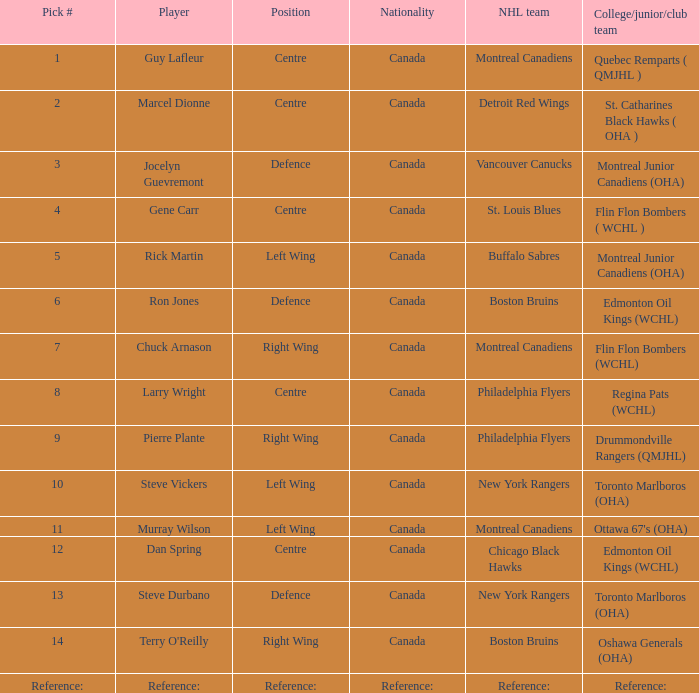Which player has a Position of defence, and a Pick # of 6? Ron Jones. 